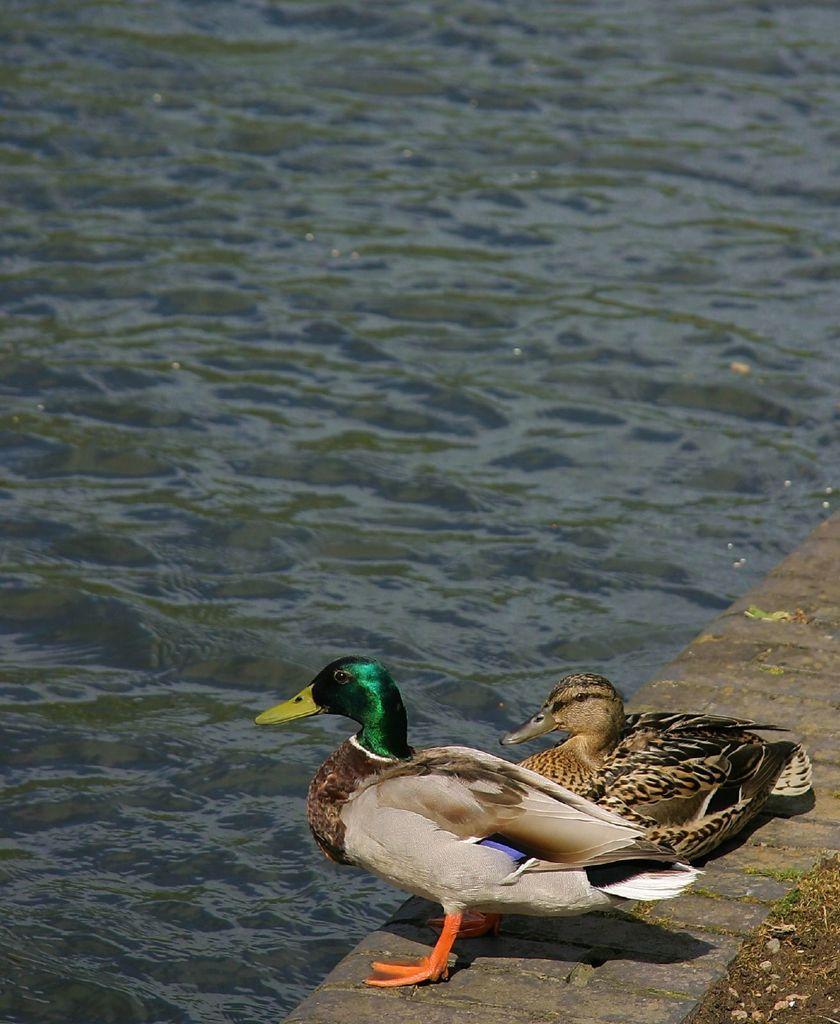How would you summarize this image in a sentence or two? In this picture there are two ducks at the bottom side of the image and there is water in the image. 